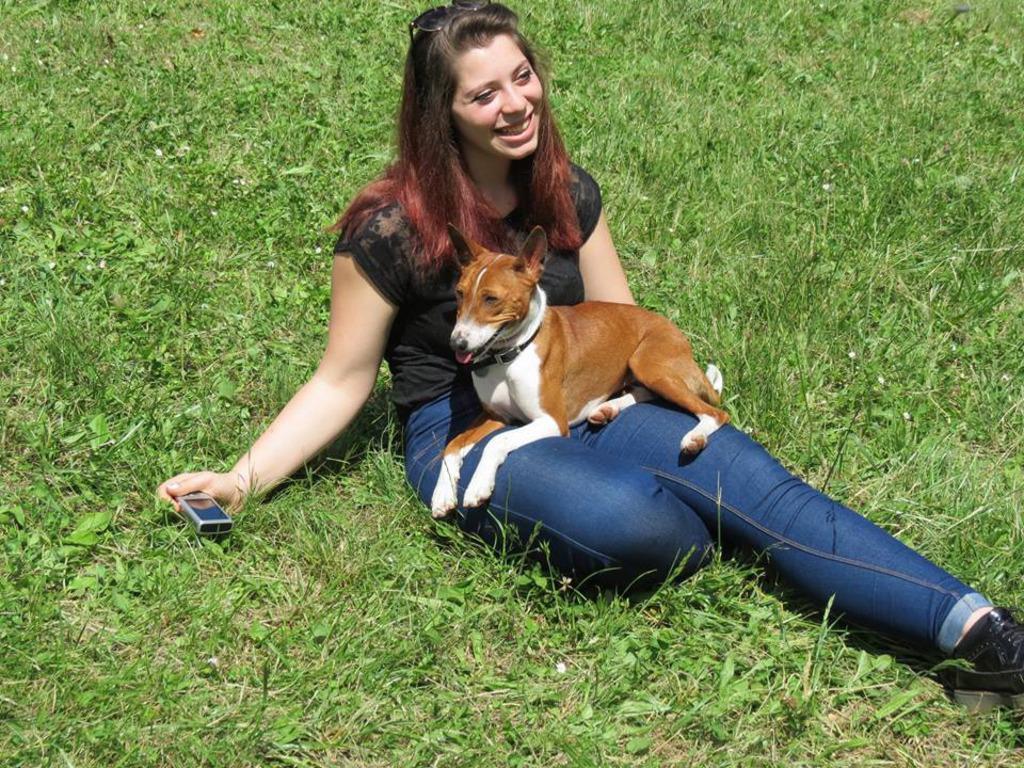Describe this image in one or two sentences. In this image we can see a woman sitting on the grass by holding a dog on her laps and a electrical device in one of her hands. 